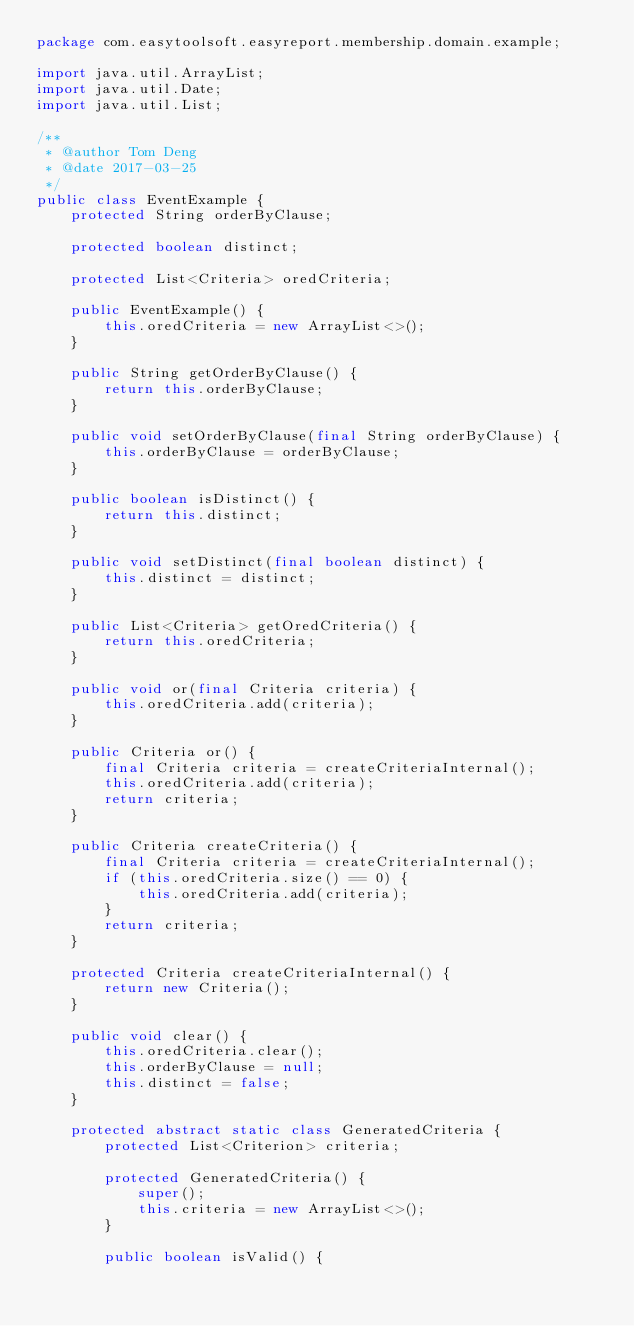Convert code to text. <code><loc_0><loc_0><loc_500><loc_500><_Java_>package com.easytoolsoft.easyreport.membership.domain.example;

import java.util.ArrayList;
import java.util.Date;
import java.util.List;

/**
 * @author Tom Deng
 * @date 2017-03-25
 */
public class EventExample {
    protected String orderByClause;

    protected boolean distinct;

    protected List<Criteria> oredCriteria;

    public EventExample() {
        this.oredCriteria = new ArrayList<>();
    }

    public String getOrderByClause() {
        return this.orderByClause;
    }

    public void setOrderByClause(final String orderByClause) {
        this.orderByClause = orderByClause;
    }

    public boolean isDistinct() {
        return this.distinct;
    }

    public void setDistinct(final boolean distinct) {
        this.distinct = distinct;
    }

    public List<Criteria> getOredCriteria() {
        return this.oredCriteria;
    }

    public void or(final Criteria criteria) {
        this.oredCriteria.add(criteria);
    }

    public Criteria or() {
        final Criteria criteria = createCriteriaInternal();
        this.oredCriteria.add(criteria);
        return criteria;
    }

    public Criteria createCriteria() {
        final Criteria criteria = createCriteriaInternal();
        if (this.oredCriteria.size() == 0) {
            this.oredCriteria.add(criteria);
        }
        return criteria;
    }

    protected Criteria createCriteriaInternal() {
        return new Criteria();
    }

    public void clear() {
        this.oredCriteria.clear();
        this.orderByClause = null;
        this.distinct = false;
    }

    protected abstract static class GeneratedCriteria {
        protected List<Criterion> criteria;

        protected GeneratedCriteria() {
            super();
            this.criteria = new ArrayList<>();
        }

        public boolean isValid() {</code> 